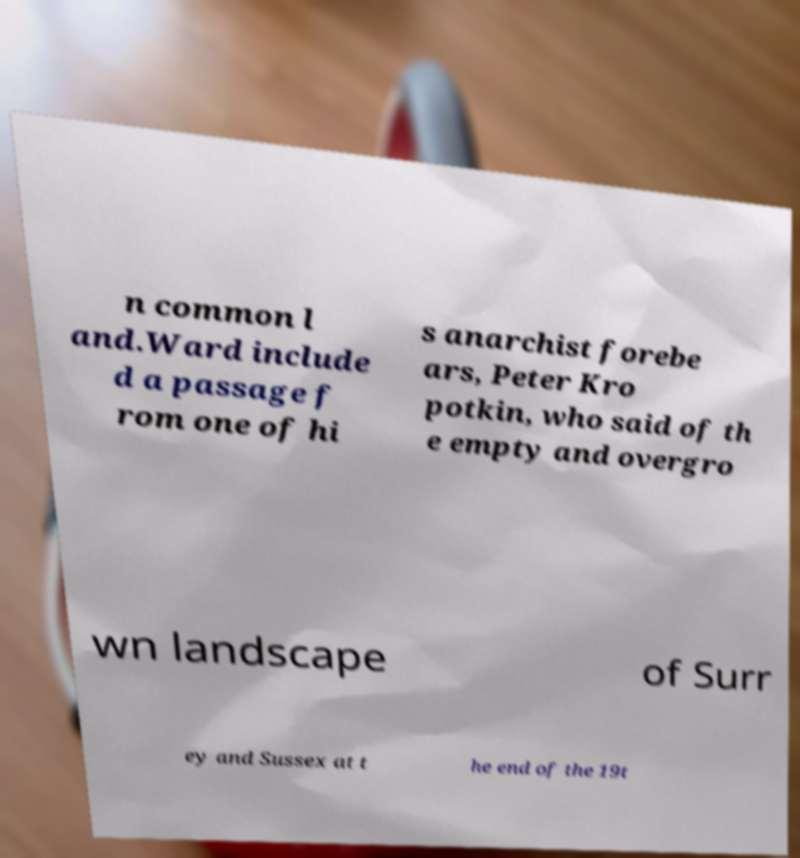Could you assist in decoding the text presented in this image and type it out clearly? n common l and.Ward include d a passage f rom one of hi s anarchist forebe ars, Peter Kro potkin, who said of th e empty and overgro wn landscape of Surr ey and Sussex at t he end of the 19t 